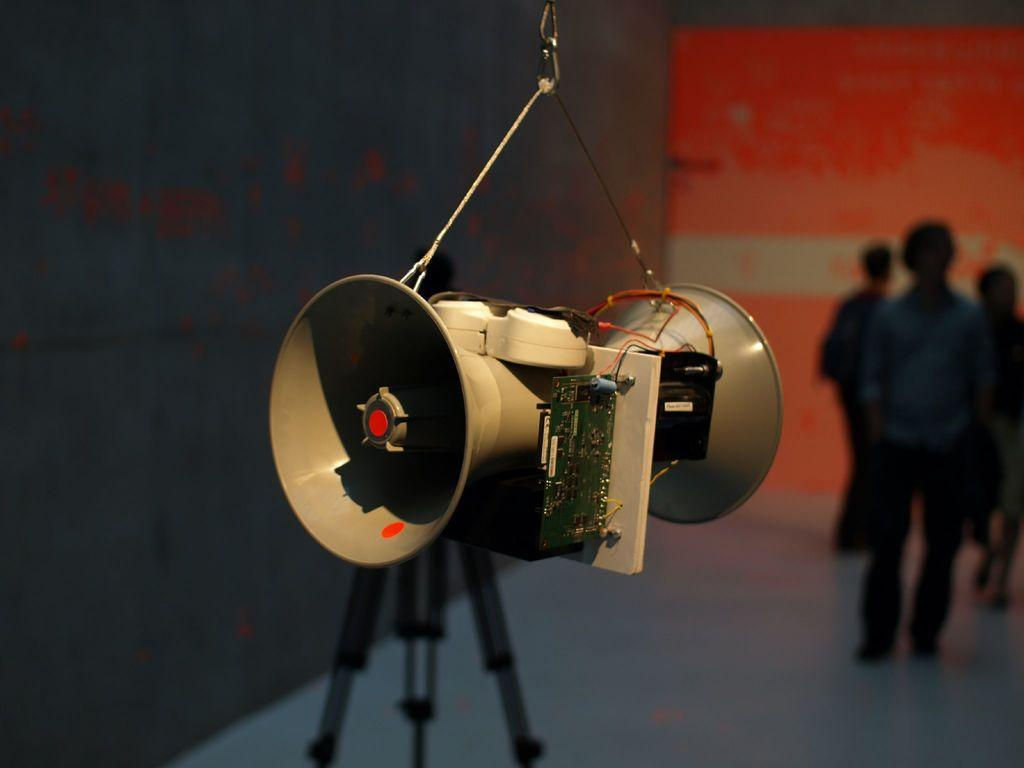What objects are present in the image related to sound? There are two speakers in the image. What else can be seen in the image related to the speakers? There are wires in the image. What is the speakers placed on or attached to? There is a stand in the image. What small electronic component can be seen in the image? There is a chip in the image. What can be observed about the people in the background of the image? There are people standing in the background of the image. What colors are predominant in the background of the image? The background has a black and orange color. What type of produce is being sold by the people in the image? There is no produce being sold in the image; the people are standing in the background. What is the income level of the people in the image? There is no information about the income level of the people in the image. 